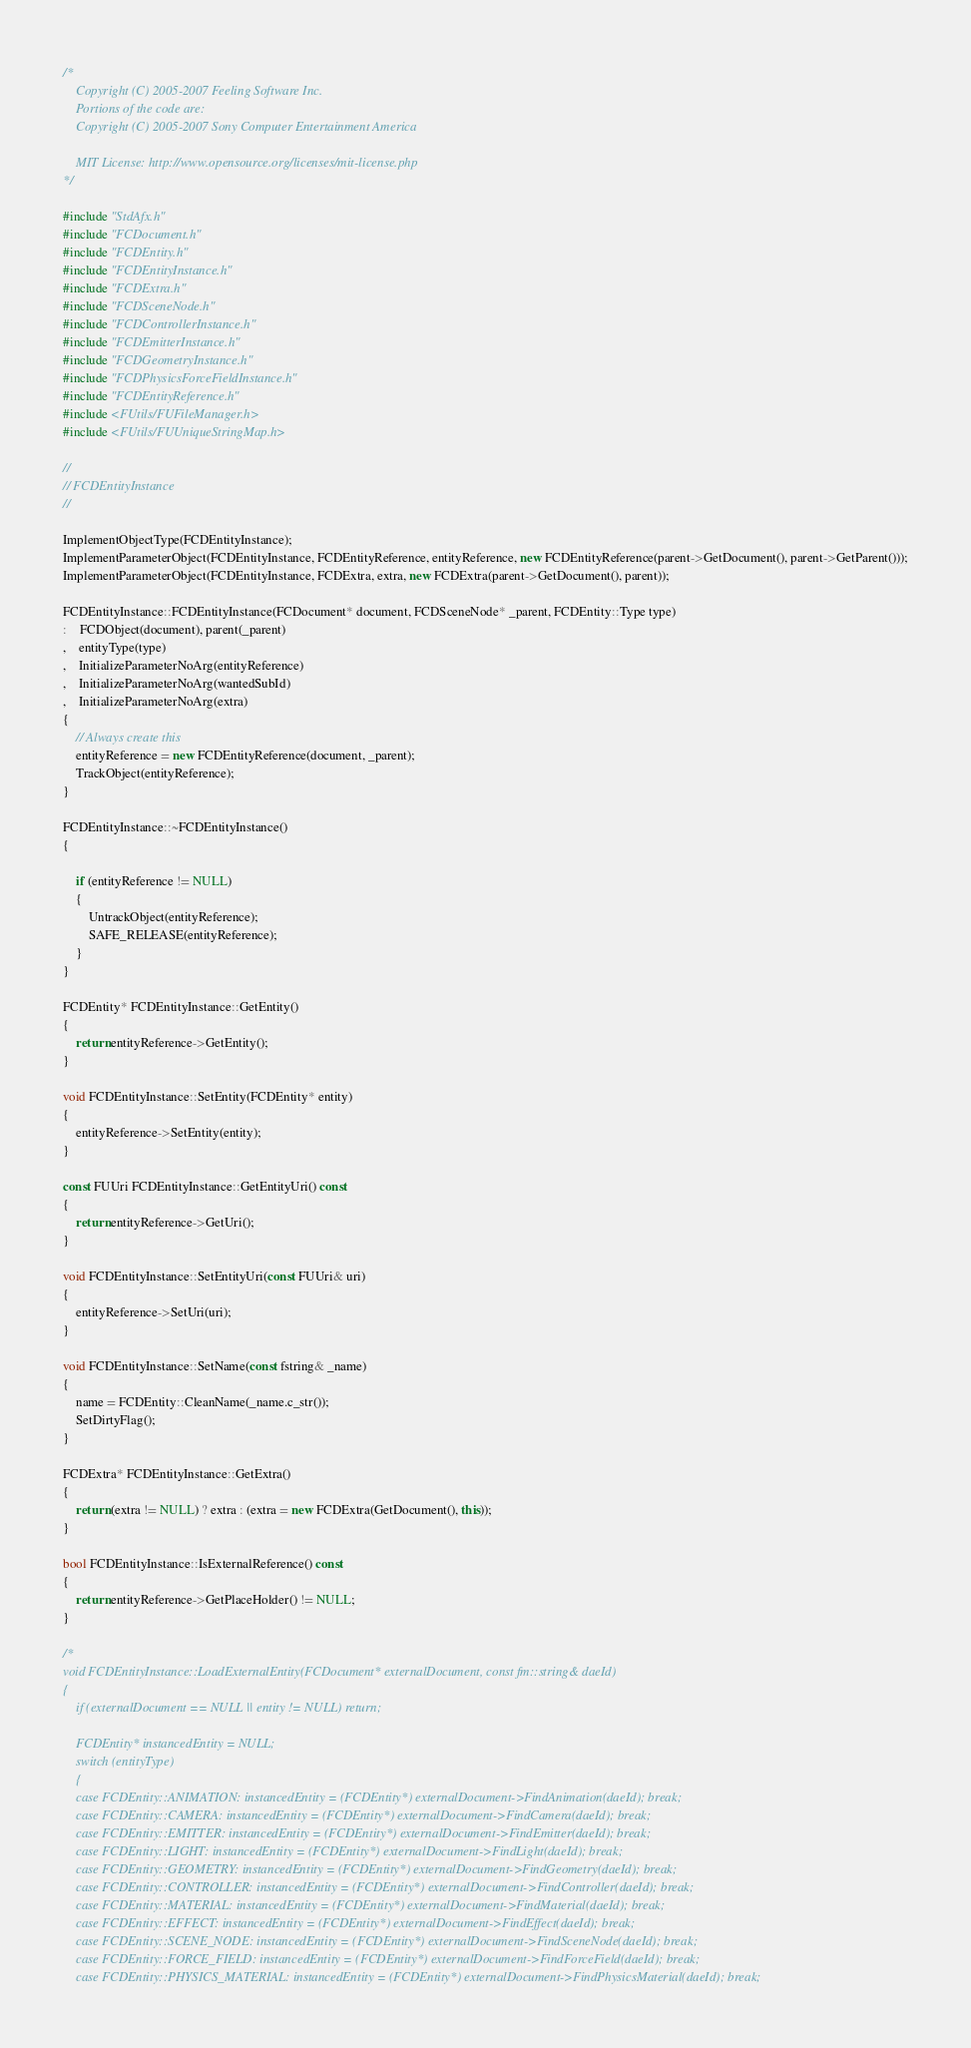Convert code to text. <code><loc_0><loc_0><loc_500><loc_500><_C++_>/*
	Copyright (C) 2005-2007 Feeling Software Inc.
	Portions of the code are:
	Copyright (C) 2005-2007 Sony Computer Entertainment America
	
	MIT License: http://www.opensource.org/licenses/mit-license.php
*/

#include "StdAfx.h"
#include "FCDocument.h"
#include "FCDEntity.h"
#include "FCDEntityInstance.h"
#include "FCDExtra.h"
#include "FCDSceneNode.h"
#include "FCDControllerInstance.h"
#include "FCDEmitterInstance.h"
#include "FCDGeometryInstance.h"
#include "FCDPhysicsForceFieldInstance.h"
#include "FCDEntityReference.h"
#include <FUtils/FUFileManager.h>
#include <FUtils/FUUniqueStringMap.h>

//
// FCDEntityInstance
//

ImplementObjectType(FCDEntityInstance);
ImplementParameterObject(FCDEntityInstance, FCDEntityReference, entityReference, new FCDEntityReference(parent->GetDocument(), parent->GetParent()));
ImplementParameterObject(FCDEntityInstance, FCDExtra, extra, new FCDExtra(parent->GetDocument(), parent));

FCDEntityInstance::FCDEntityInstance(FCDocument* document, FCDSceneNode* _parent, FCDEntity::Type type)
:	FCDObject(document), parent(_parent)
,	entityType(type)
,	InitializeParameterNoArg(entityReference)
,	InitializeParameterNoArg(wantedSubId)
,	InitializeParameterNoArg(extra)
{
	// Always create this
	entityReference = new FCDEntityReference(document, _parent);
	TrackObject(entityReference);
}

FCDEntityInstance::~FCDEntityInstance()
{

	if (entityReference != NULL)
	{
		UntrackObject(entityReference);
		SAFE_RELEASE(entityReference);
	}
}

FCDEntity* FCDEntityInstance::GetEntity() 
{ 
	return entityReference->GetEntity(); 
}

void FCDEntityInstance::SetEntity(FCDEntity* entity) 
{ 
	entityReference->SetEntity(entity); 
}

const FUUri FCDEntityInstance::GetEntityUri() const 
{ 
	return entityReference->GetUri(); 
}

void FCDEntityInstance::SetEntityUri(const FUUri& uri) 
{ 
	entityReference->SetUri(uri); 
}

void FCDEntityInstance::SetName(const fstring& _name) 
{
	name = FCDEntity::CleanName(_name.c_str());
	SetDirtyFlag();
}

FCDExtra* FCDEntityInstance::GetExtra()
{
	return (extra != NULL) ? extra : (extra = new FCDExtra(GetDocument(), this));
}

bool FCDEntityInstance::IsExternalReference() const
{ 
	return entityReference->GetPlaceHolder() != NULL; 
}

/*
void FCDEntityInstance::LoadExternalEntity(FCDocument* externalDocument, const fm::string& daeId)
{
	if (externalDocument == NULL || entity != NULL) return;

	FCDEntity* instancedEntity = NULL;
	switch (entityType)
	{
	case FCDEntity::ANIMATION: instancedEntity = (FCDEntity*) externalDocument->FindAnimation(daeId); break;
	case FCDEntity::CAMERA: instancedEntity = (FCDEntity*) externalDocument->FindCamera(daeId); break;
	case FCDEntity::EMITTER: instancedEntity = (FCDEntity*) externalDocument->FindEmitter(daeId); break;
	case FCDEntity::LIGHT: instancedEntity = (FCDEntity*) externalDocument->FindLight(daeId); break;
	case FCDEntity::GEOMETRY: instancedEntity = (FCDEntity*) externalDocument->FindGeometry(daeId); break;
	case FCDEntity::CONTROLLER: instancedEntity = (FCDEntity*) externalDocument->FindController(daeId); break;
	case FCDEntity::MATERIAL: instancedEntity = (FCDEntity*) externalDocument->FindMaterial(daeId); break;
	case FCDEntity::EFFECT: instancedEntity = (FCDEntity*) externalDocument->FindEffect(daeId); break;
	case FCDEntity::SCENE_NODE: instancedEntity = (FCDEntity*) externalDocument->FindSceneNode(daeId); break;
	case FCDEntity::FORCE_FIELD: instancedEntity = (FCDEntity*) externalDocument->FindForceField(daeId); break;
	case FCDEntity::PHYSICS_MATERIAL: instancedEntity = (FCDEntity*) externalDocument->FindPhysicsMaterial(daeId); break;</code> 